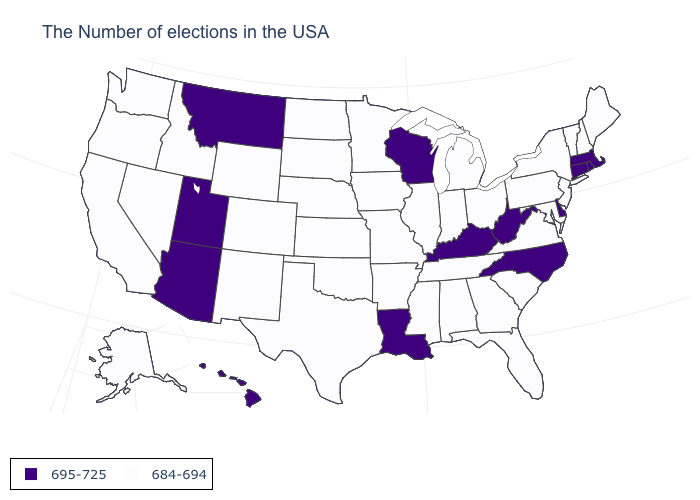Name the states that have a value in the range 684-694?
Short answer required. Maine, New Hampshire, Vermont, New York, New Jersey, Maryland, Pennsylvania, Virginia, South Carolina, Ohio, Florida, Georgia, Michigan, Indiana, Alabama, Tennessee, Illinois, Mississippi, Missouri, Arkansas, Minnesota, Iowa, Kansas, Nebraska, Oklahoma, Texas, South Dakota, North Dakota, Wyoming, Colorado, New Mexico, Idaho, Nevada, California, Washington, Oregon, Alaska. Is the legend a continuous bar?
Keep it brief. No. Which states have the highest value in the USA?
Answer briefly. Massachusetts, Rhode Island, Connecticut, Delaware, North Carolina, West Virginia, Kentucky, Wisconsin, Louisiana, Utah, Montana, Arizona, Hawaii. What is the value of California?
Quick response, please. 684-694. What is the lowest value in states that border Nebraska?
Short answer required. 684-694. What is the highest value in the USA?
Keep it brief. 695-725. Name the states that have a value in the range 684-694?
Concise answer only. Maine, New Hampshire, Vermont, New York, New Jersey, Maryland, Pennsylvania, Virginia, South Carolina, Ohio, Florida, Georgia, Michigan, Indiana, Alabama, Tennessee, Illinois, Mississippi, Missouri, Arkansas, Minnesota, Iowa, Kansas, Nebraska, Oklahoma, Texas, South Dakota, North Dakota, Wyoming, Colorado, New Mexico, Idaho, Nevada, California, Washington, Oregon, Alaska. Name the states that have a value in the range 695-725?
Keep it brief. Massachusetts, Rhode Island, Connecticut, Delaware, North Carolina, West Virginia, Kentucky, Wisconsin, Louisiana, Utah, Montana, Arizona, Hawaii. Does Louisiana have the lowest value in the South?
Keep it brief. No. Does Maryland have the same value as New Jersey?
Concise answer only. Yes. Is the legend a continuous bar?
Answer briefly. No. Does Connecticut have the lowest value in the Northeast?
Write a very short answer. No. Does Utah have the lowest value in the West?
Concise answer only. No. 